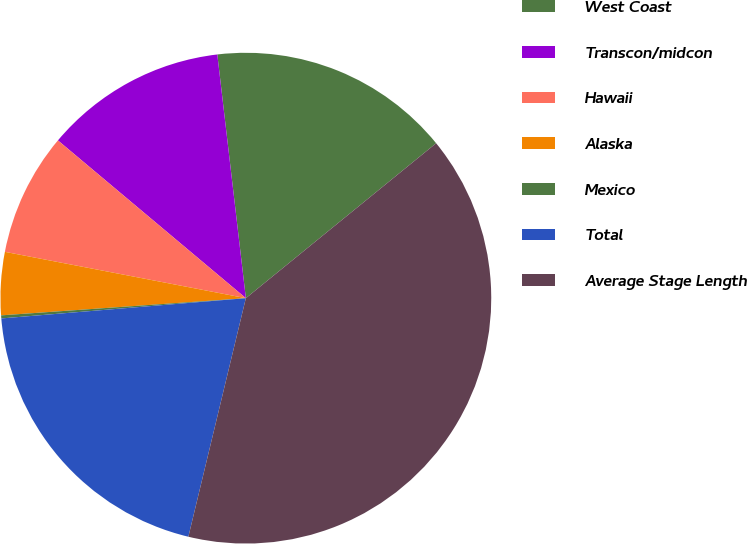Convert chart to OTSL. <chart><loc_0><loc_0><loc_500><loc_500><pie_chart><fcel>West Coast<fcel>Transcon/midcon<fcel>Hawaii<fcel>Alaska<fcel>Mexico<fcel>Total<fcel>Average Stage Length<nl><fcel>15.98%<fcel>12.03%<fcel>8.09%<fcel>4.14%<fcel>0.2%<fcel>19.92%<fcel>39.64%<nl></chart> 